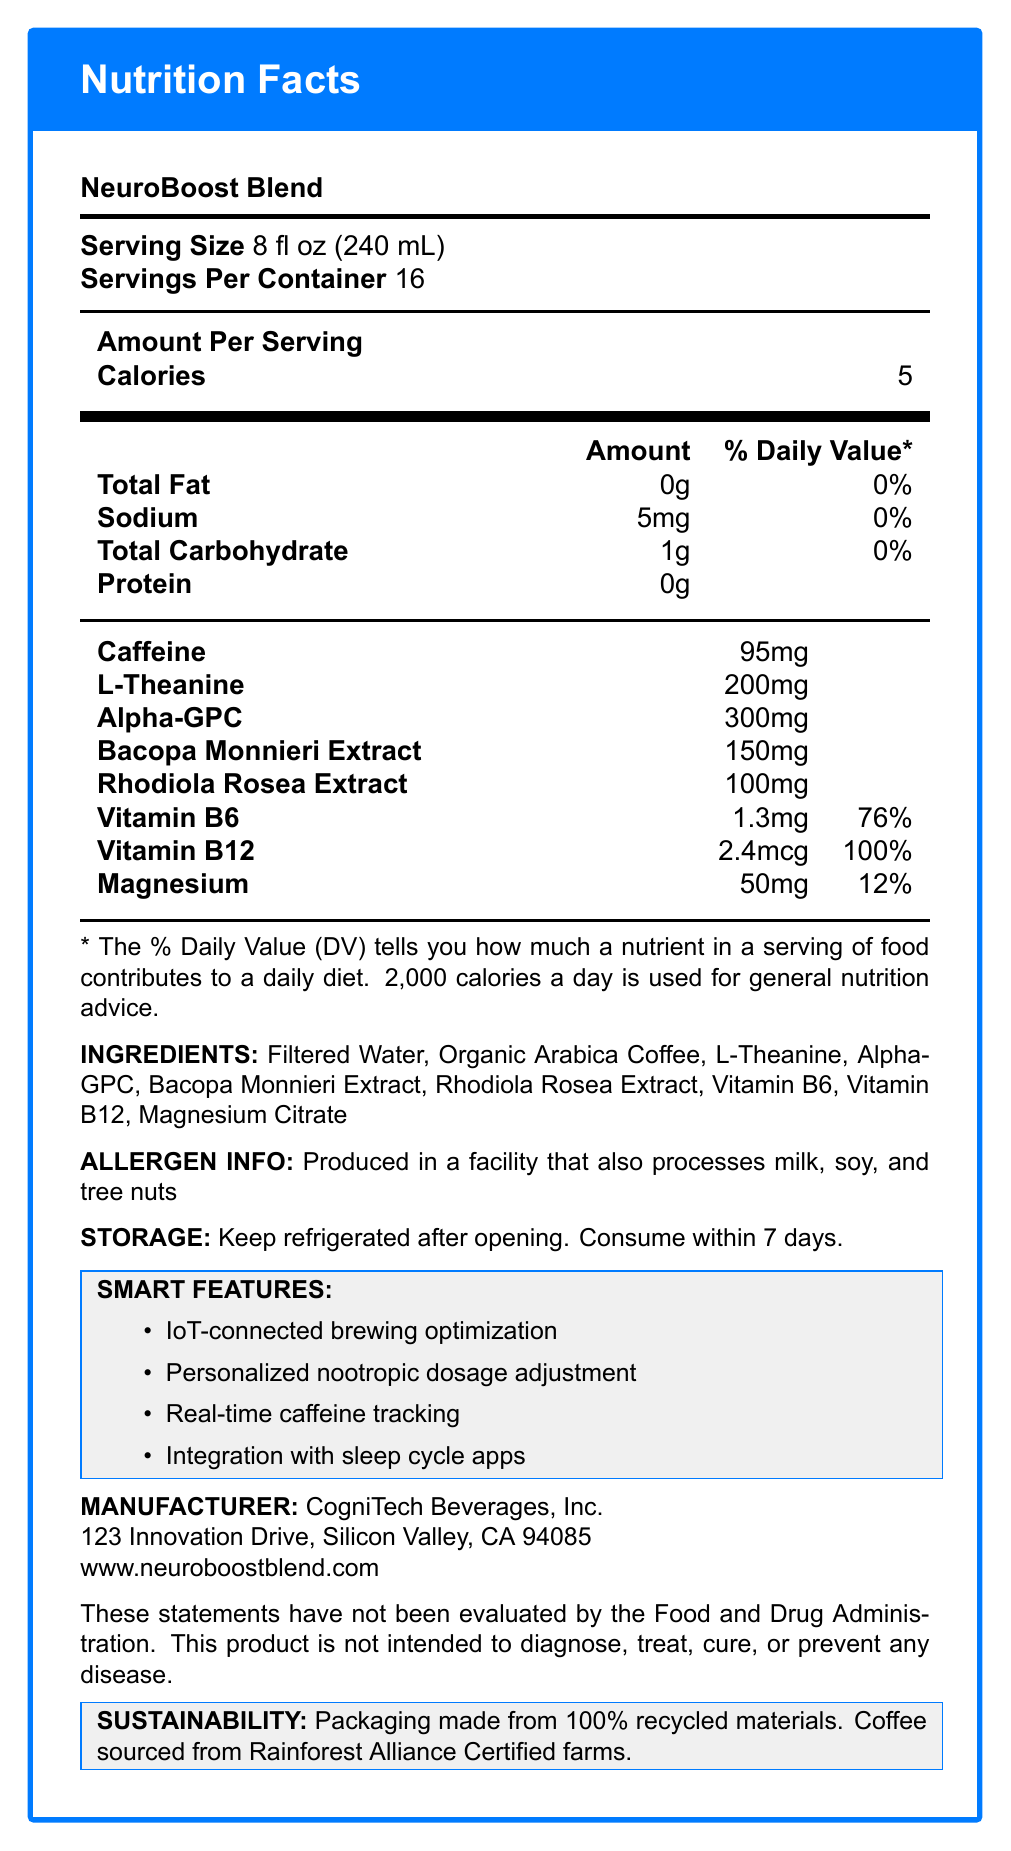What is the serving size of NeuroBoost Blend? The serving size is explicitly mentioned as "8 fl oz (240 mL)" in the document.
Answer: 8 fl oz (240 mL) How many servings are there per container? The document specifies that there are 16 servings per container.
Answer: 16 How many calories are there per serving? The document states that each serving has 5 calories.
Answer: 5 What amount of caffeine is present per serving? The document lists the caffeine content per serving as 95mg.
Answer: 95mg Which nootropic has the highest amount per serving in NeuroBoost Blend? Alpha-GPC has 300mg per serving, which is the highest among the nootropics listed.
Answer: Alpha-GPC How much sodium is present per serving? A. 0mg B. 5mg C. 10mg D. 50mg The document indicates that each serving contains 5mg of sodium.
Answer: B. 5mg What is the daily value percentage of Vitamin B6 per serving? A. 50% B. 76% C. 100% D. 120% The document shows that Vitamin B6 has a 76% daily value per serving.
Answer: B. 76% Does the product contain any protein? The document lists the protein content as 0g.
Answer: No Is NeuroBoost Blend produced in a facility that processes tree nuts? The allergen information section of the document mentions that it is produced in a facility that processes tree nuts among other allergens.
Answer: Yes Summarize the main idea of the document. The document contains detailed information about various nutritional aspects of NeuroBoost Blend, including calories, nootropics, vitamins, minerals, and other essential data, along with smart connected features and manufacturer information.
Answer: The document provides nutrition facts and additional information for NeuroBoost Blend, an IoT-connected coffee with added nootropics. It lists serving sizes, nutrient amounts, ingredients, allergen info, storage instructions, smart features, and manufacturer's details. What are the storage instructions for NeuroBoost Blend? The document clearly states to keep the product refrigerated after opening and consume within 7 days.
Answer: Keep refrigerated after opening. Consume within 7 days. Which vitamin has the highest daily value percentage per serving? The document indicates that Vitamin B12 has a daily value percentage of 100% per serving, which is the highest among the listed vitamins and minerals.
Answer: Vitamin B12 What are some of the smart features of NeuroBoost Blend? The document lists these as the smart features of the product.
Answer: IoT-connected brewing optimization, Personalized nootropic dosage adjustment, Real-time caffeine tracking, Integration with sleep cycle apps Can you determine the price of a NeuroBoost Blend container from the document? The document does not provide any information regarding the price of the container.
Answer: Cannot be determined What type of coffee is used in NeuroBoost Blend? The ingredients list states "Organic Arabica Coffee" as one of the components.
Answer: Organic Arabica Coffee What is the manufacturer's website? The document mentions the manufacturer's website as www.neuroboostblend.com.
Answer: www.neuroboostblend.com What is the sustainability claim mentioned in the document? The document mentions that the packaging is made from 100% recycled materials, and the coffee is sourced from Rainforest Alliance Certified farms.
Answer: Packaging made from 100% recycled materials. Coffee sourced from Rainforest Alliance Certified farms. What is the street address of the manufacturer? The manufacturer info section specifies the street address as 123 Innovation Drive, Silicon Valley, CA 94085.
Answer: 123 Innovation Drive, Silicon Valley, CA 94085 How many types of nootropics are there in NeuroBoost Blend? The document lists four nootropics: L-Theanine, Alpha-GPC, Bacopa Monnieri Extract, and Rhodiola Rosea Extract.
Answer: 4 